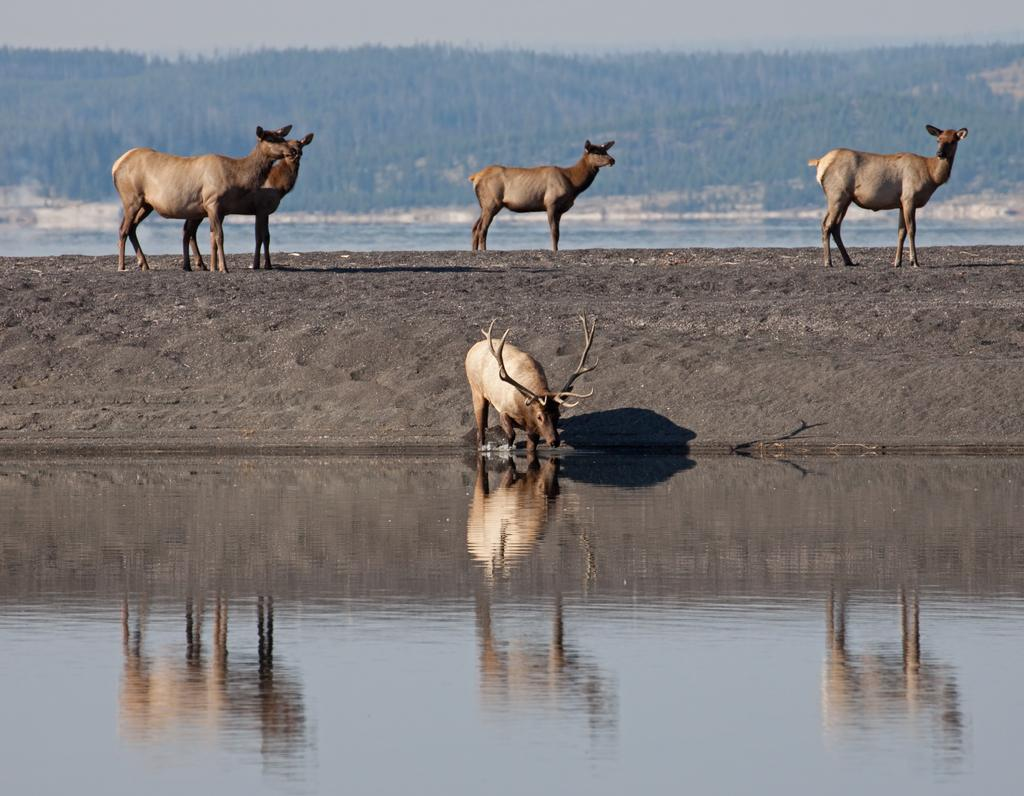What is located at the bottom side of the image? There is water at the bottom side of the image. What is the deer in the image doing? A deer is drinking water in the image. What other animals can be seen in the image besides the deer? There are animals in the image, but the specific type of animals is not mentioned. How is the water positioned in the image? The water appears to be on a slope. What type of vegetation is present on the slope ground? Trees are present on the slope ground. What can be seen in the background of the image? The sky is visible in the background of the image. What type of engine is powering the deer in the image? There is no engine present in the image, and the deer is not powered by any engine. What is the range of the scale used to measure the water in the image? There is no scale present in the image, so it is not possible to determine the range of any scale. 